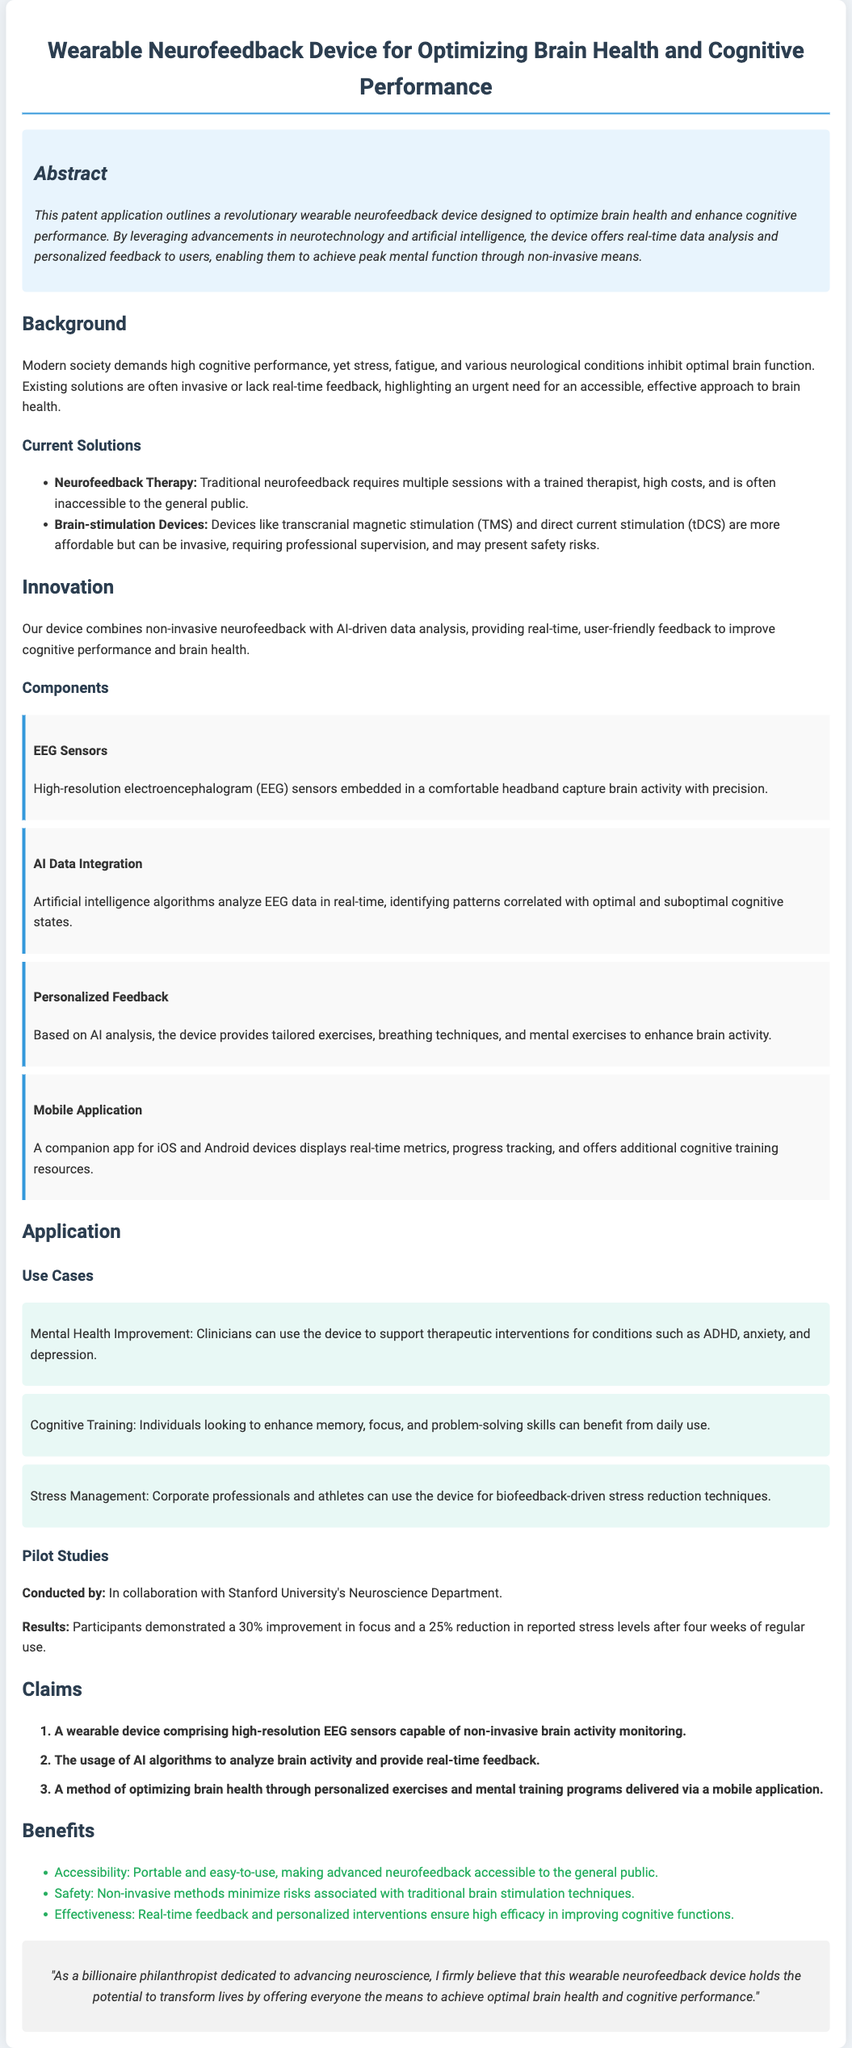What is the title of the patent application? The title appears at the top of the document, summarizing the main focus of the invention.
Answer: Wearable Neurofeedback Device for Optimizing Brain Health and Cognitive Performance What are the components listed in the innovation section? The innovation section details multiple technologies that make up the device, listed as components.
Answer: EEG Sensors, AI Data Integration, Personalized Feedback, Mobile Application What percentage improvement in focus was reported in pilot studies? The pilot studies section provides specific quantitative results from participant feedback.
Answer: 30% What type of method does the device propose for optimizing brain health? The claims section specifies the techniques intended for enhancing cognitive functions through the device.
Answer: Personalized exercises and mental training programs Who conducted the pilot studies? The document credits a specific institution for collaboration during the pilot studies.
Answer: Stanford University's Neuroscience Department What are the main benefits of the device mentioned in the document? The benefits section outlines key advantages of the device compared to traditional solutions.
Answer: Accessibility, Safety, Effectiveness What kind of application does the device have for athletes? The use case section outlines potential applications for specific groups, including athletes.
Answer: Biofeedback-driven stress reduction techniques How many claims are made in the patent application? The claims section includes a numbered list indicating the total claims being made regarding the invention.
Answer: 3 